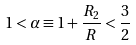Convert formula to latex. <formula><loc_0><loc_0><loc_500><loc_500>1 < \alpha \equiv 1 + \frac { R _ { 2 } } { R } < \frac { 3 } { 2 }</formula> 